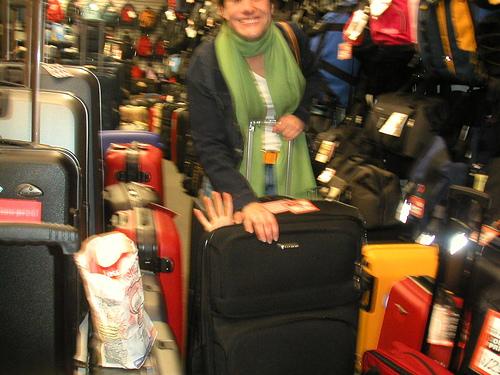Is there anything in the suitcase?
Keep it brief. Yes. What is in the suitcase?
Give a very brief answer. Person. Are there any red suitcases?
Keep it brief. Yes. 